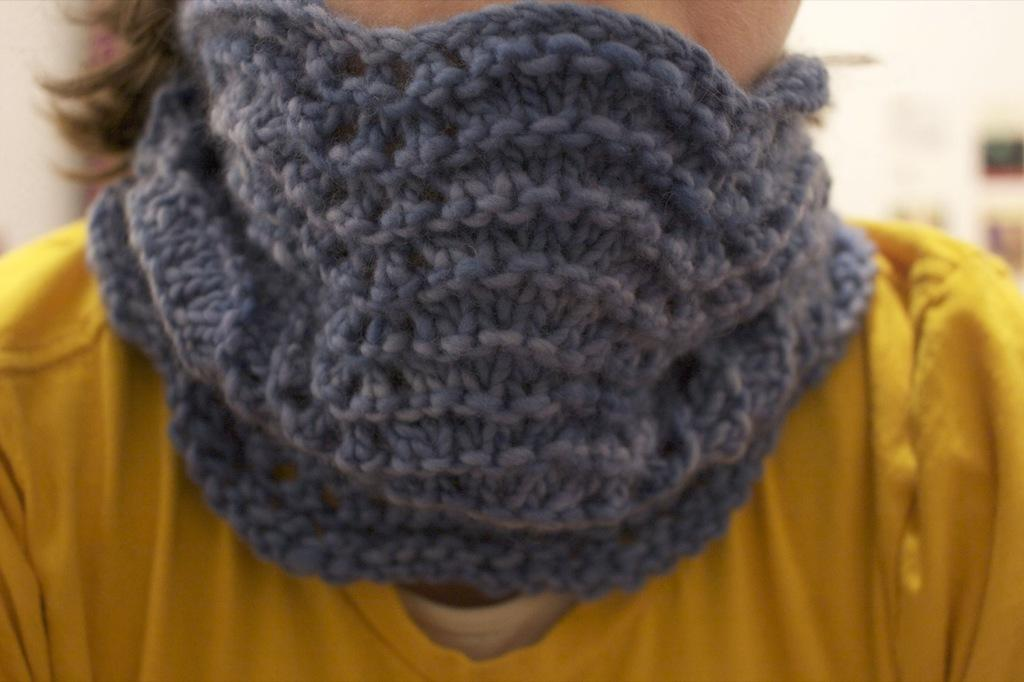What type of mask is in the image? There is a woolen mask in the image. What is the man wearing in the image? The man is wearing a yellow dress in the image. What type of bone can be seen in the image? There is no bone present in the image. What type of education is the man receiving in the image? There is no indication of education in the image; it only shows a man wearing a yellow dress and a woolen mask. 